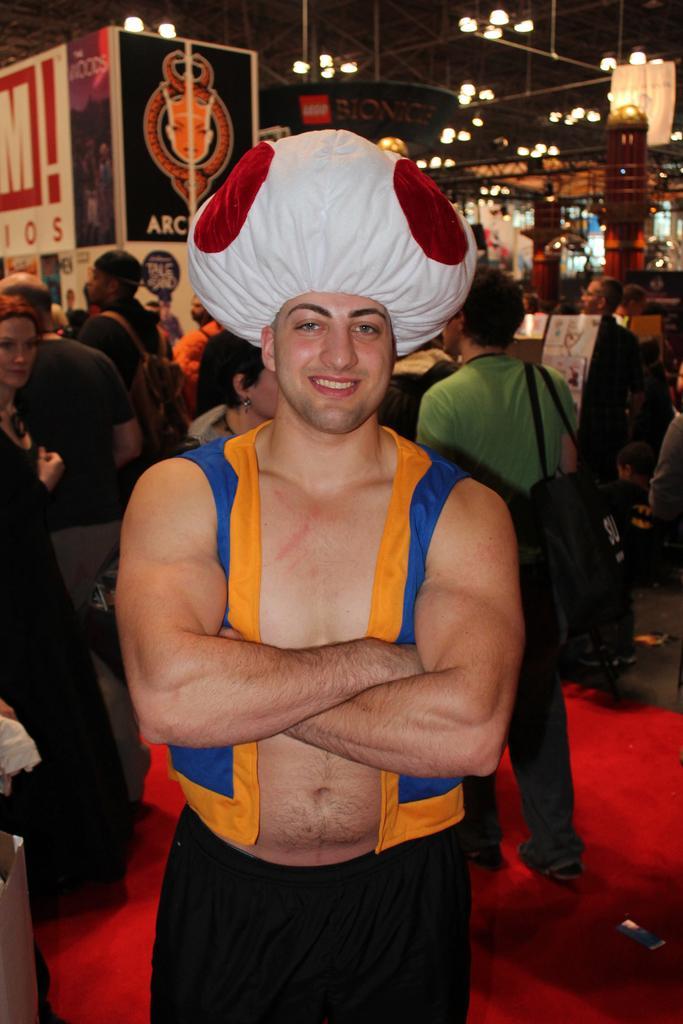Please provide a concise description of this image. There is a man in the center of the image, it seems like he is wearing a costume. There are people, light, other objects, posters and a roof in the background area. 